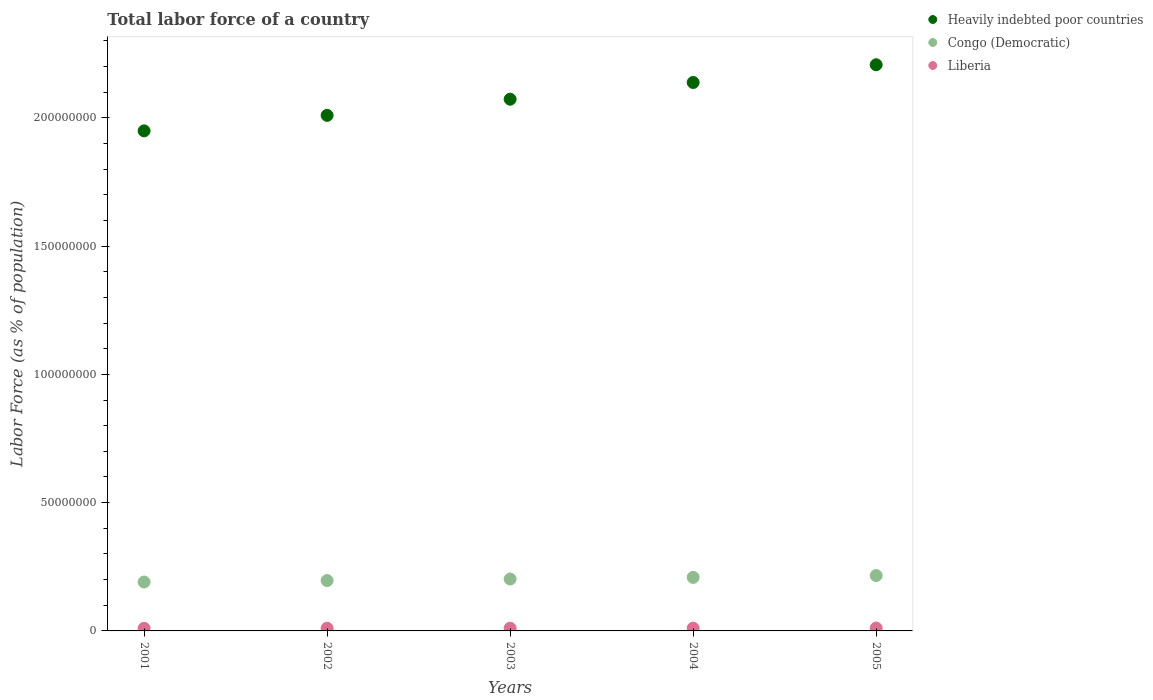How many different coloured dotlines are there?
Your answer should be very brief. 3. What is the percentage of labor force in Heavily indebted poor countries in 2002?
Provide a succinct answer. 2.01e+08. Across all years, what is the maximum percentage of labor force in Heavily indebted poor countries?
Offer a very short reply. 2.21e+08. Across all years, what is the minimum percentage of labor force in Liberia?
Offer a very short reply. 1.02e+06. In which year was the percentage of labor force in Liberia maximum?
Your answer should be very brief. 2005. In which year was the percentage of labor force in Congo (Democratic) minimum?
Your answer should be very brief. 2001. What is the total percentage of labor force in Liberia in the graph?
Make the answer very short. 5.37e+06. What is the difference between the percentage of labor force in Heavily indebted poor countries in 2001 and that in 2005?
Provide a succinct answer. -2.58e+07. What is the difference between the percentage of labor force in Liberia in 2004 and the percentage of labor force in Heavily indebted poor countries in 2003?
Your response must be concise. -2.06e+08. What is the average percentage of labor force in Liberia per year?
Your answer should be compact. 1.07e+06. In the year 2003, what is the difference between the percentage of labor force in Congo (Democratic) and percentage of labor force in Liberia?
Ensure brevity in your answer.  1.92e+07. In how many years, is the percentage of labor force in Congo (Democratic) greater than 210000000 %?
Provide a succinct answer. 0. What is the ratio of the percentage of labor force in Congo (Democratic) in 2001 to that in 2004?
Your answer should be compact. 0.91. Is the percentage of labor force in Heavily indebted poor countries in 2002 less than that in 2004?
Make the answer very short. Yes. What is the difference between the highest and the second highest percentage of labor force in Congo (Democratic)?
Make the answer very short. 7.05e+05. What is the difference between the highest and the lowest percentage of labor force in Congo (Democratic)?
Provide a short and direct response. 2.51e+06. In how many years, is the percentage of labor force in Congo (Democratic) greater than the average percentage of labor force in Congo (Democratic) taken over all years?
Provide a short and direct response. 2. Is the sum of the percentage of labor force in Heavily indebted poor countries in 2002 and 2003 greater than the maximum percentage of labor force in Congo (Democratic) across all years?
Give a very brief answer. Yes. Is it the case that in every year, the sum of the percentage of labor force in Congo (Democratic) and percentage of labor force in Heavily indebted poor countries  is greater than the percentage of labor force in Liberia?
Provide a succinct answer. Yes. Does the percentage of labor force in Liberia monotonically increase over the years?
Your answer should be very brief. Yes. Is the percentage of labor force in Liberia strictly greater than the percentage of labor force in Congo (Democratic) over the years?
Offer a very short reply. No. Is the percentage of labor force in Liberia strictly less than the percentage of labor force in Heavily indebted poor countries over the years?
Your answer should be compact. Yes. What is the difference between two consecutive major ticks on the Y-axis?
Make the answer very short. 5.00e+07. Are the values on the major ticks of Y-axis written in scientific E-notation?
Provide a short and direct response. No. Does the graph contain grids?
Provide a succinct answer. No. Where does the legend appear in the graph?
Your response must be concise. Top right. How are the legend labels stacked?
Your response must be concise. Vertical. What is the title of the graph?
Offer a terse response. Total labor force of a country. Does "Bolivia" appear as one of the legend labels in the graph?
Your answer should be very brief. No. What is the label or title of the Y-axis?
Give a very brief answer. Labor Force (as % of population). What is the Labor Force (as % of population) in Heavily indebted poor countries in 2001?
Make the answer very short. 1.95e+08. What is the Labor Force (as % of population) of Congo (Democratic) in 2001?
Your answer should be compact. 1.91e+07. What is the Labor Force (as % of population) in Liberia in 2001?
Your answer should be compact. 1.02e+06. What is the Labor Force (as % of population) in Heavily indebted poor countries in 2002?
Provide a succinct answer. 2.01e+08. What is the Labor Force (as % of population) of Congo (Democratic) in 2002?
Provide a succinct answer. 1.96e+07. What is the Labor Force (as % of population) in Liberia in 2002?
Your response must be concise. 1.05e+06. What is the Labor Force (as % of population) of Heavily indebted poor countries in 2003?
Offer a terse response. 2.07e+08. What is the Labor Force (as % of population) of Congo (Democratic) in 2003?
Your answer should be very brief. 2.02e+07. What is the Labor Force (as % of population) of Liberia in 2003?
Provide a succinct answer. 1.07e+06. What is the Labor Force (as % of population) in Heavily indebted poor countries in 2004?
Make the answer very short. 2.14e+08. What is the Labor Force (as % of population) of Congo (Democratic) in 2004?
Provide a short and direct response. 2.09e+07. What is the Labor Force (as % of population) in Liberia in 2004?
Keep it short and to the point. 1.09e+06. What is the Labor Force (as % of population) of Heavily indebted poor countries in 2005?
Provide a short and direct response. 2.21e+08. What is the Labor Force (as % of population) in Congo (Democratic) in 2005?
Your response must be concise. 2.16e+07. What is the Labor Force (as % of population) in Liberia in 2005?
Provide a short and direct response. 1.12e+06. Across all years, what is the maximum Labor Force (as % of population) of Heavily indebted poor countries?
Make the answer very short. 2.21e+08. Across all years, what is the maximum Labor Force (as % of population) of Congo (Democratic)?
Offer a very short reply. 2.16e+07. Across all years, what is the maximum Labor Force (as % of population) in Liberia?
Offer a terse response. 1.12e+06. Across all years, what is the minimum Labor Force (as % of population) in Heavily indebted poor countries?
Ensure brevity in your answer.  1.95e+08. Across all years, what is the minimum Labor Force (as % of population) of Congo (Democratic)?
Your response must be concise. 1.91e+07. Across all years, what is the minimum Labor Force (as % of population) in Liberia?
Keep it short and to the point. 1.02e+06. What is the total Labor Force (as % of population) in Heavily indebted poor countries in the graph?
Offer a very short reply. 1.04e+09. What is the total Labor Force (as % of population) in Congo (Democratic) in the graph?
Your answer should be compact. 1.01e+08. What is the total Labor Force (as % of population) in Liberia in the graph?
Provide a short and direct response. 5.37e+06. What is the difference between the Labor Force (as % of population) of Heavily indebted poor countries in 2001 and that in 2002?
Ensure brevity in your answer.  -6.04e+06. What is the difference between the Labor Force (as % of population) of Congo (Democratic) in 2001 and that in 2002?
Keep it short and to the point. -5.72e+05. What is the difference between the Labor Force (as % of population) in Liberia in 2001 and that in 2002?
Offer a terse response. -2.57e+04. What is the difference between the Labor Force (as % of population) of Heavily indebted poor countries in 2001 and that in 2003?
Offer a very short reply. -1.23e+07. What is the difference between the Labor Force (as % of population) of Congo (Democratic) in 2001 and that in 2003?
Keep it short and to the point. -1.17e+06. What is the difference between the Labor Force (as % of population) of Liberia in 2001 and that in 2003?
Ensure brevity in your answer.  -4.64e+04. What is the difference between the Labor Force (as % of population) of Heavily indebted poor countries in 2001 and that in 2004?
Give a very brief answer. -1.89e+07. What is the difference between the Labor Force (as % of population) in Congo (Democratic) in 2001 and that in 2004?
Your answer should be compact. -1.81e+06. What is the difference between the Labor Force (as % of population) in Liberia in 2001 and that in 2004?
Ensure brevity in your answer.  -6.97e+04. What is the difference between the Labor Force (as % of population) of Heavily indebted poor countries in 2001 and that in 2005?
Your answer should be compact. -2.58e+07. What is the difference between the Labor Force (as % of population) in Congo (Democratic) in 2001 and that in 2005?
Offer a terse response. -2.51e+06. What is the difference between the Labor Force (as % of population) of Liberia in 2001 and that in 2005?
Offer a terse response. -1.00e+05. What is the difference between the Labor Force (as % of population) in Heavily indebted poor countries in 2002 and that in 2003?
Your answer should be very brief. -6.30e+06. What is the difference between the Labor Force (as % of population) in Congo (Democratic) in 2002 and that in 2003?
Provide a succinct answer. -5.96e+05. What is the difference between the Labor Force (as % of population) of Liberia in 2002 and that in 2003?
Offer a very short reply. -2.07e+04. What is the difference between the Labor Force (as % of population) of Heavily indebted poor countries in 2002 and that in 2004?
Keep it short and to the point. -1.28e+07. What is the difference between the Labor Force (as % of population) in Congo (Democratic) in 2002 and that in 2004?
Your answer should be very brief. -1.23e+06. What is the difference between the Labor Force (as % of population) in Liberia in 2002 and that in 2004?
Your answer should be compact. -4.40e+04. What is the difference between the Labor Force (as % of population) in Heavily indebted poor countries in 2002 and that in 2005?
Keep it short and to the point. -1.97e+07. What is the difference between the Labor Force (as % of population) in Congo (Democratic) in 2002 and that in 2005?
Your answer should be compact. -1.94e+06. What is the difference between the Labor Force (as % of population) of Liberia in 2002 and that in 2005?
Your response must be concise. -7.46e+04. What is the difference between the Labor Force (as % of population) in Heavily indebted poor countries in 2003 and that in 2004?
Your answer should be compact. -6.52e+06. What is the difference between the Labor Force (as % of population) in Congo (Democratic) in 2003 and that in 2004?
Your answer should be compact. -6.39e+05. What is the difference between the Labor Force (as % of population) of Liberia in 2003 and that in 2004?
Make the answer very short. -2.33e+04. What is the difference between the Labor Force (as % of population) in Heavily indebted poor countries in 2003 and that in 2005?
Keep it short and to the point. -1.34e+07. What is the difference between the Labor Force (as % of population) of Congo (Democratic) in 2003 and that in 2005?
Ensure brevity in your answer.  -1.34e+06. What is the difference between the Labor Force (as % of population) of Liberia in 2003 and that in 2005?
Your response must be concise. -5.38e+04. What is the difference between the Labor Force (as % of population) of Heavily indebted poor countries in 2004 and that in 2005?
Your answer should be compact. -6.91e+06. What is the difference between the Labor Force (as % of population) of Congo (Democratic) in 2004 and that in 2005?
Give a very brief answer. -7.05e+05. What is the difference between the Labor Force (as % of population) of Liberia in 2004 and that in 2005?
Provide a succinct answer. -3.06e+04. What is the difference between the Labor Force (as % of population) in Heavily indebted poor countries in 2001 and the Labor Force (as % of population) in Congo (Democratic) in 2002?
Your answer should be compact. 1.75e+08. What is the difference between the Labor Force (as % of population) in Heavily indebted poor countries in 2001 and the Labor Force (as % of population) in Liberia in 2002?
Offer a terse response. 1.94e+08. What is the difference between the Labor Force (as % of population) of Congo (Democratic) in 2001 and the Labor Force (as % of population) of Liberia in 2002?
Provide a short and direct response. 1.80e+07. What is the difference between the Labor Force (as % of population) in Heavily indebted poor countries in 2001 and the Labor Force (as % of population) in Congo (Democratic) in 2003?
Your response must be concise. 1.75e+08. What is the difference between the Labor Force (as % of population) in Heavily indebted poor countries in 2001 and the Labor Force (as % of population) in Liberia in 2003?
Keep it short and to the point. 1.94e+08. What is the difference between the Labor Force (as % of population) of Congo (Democratic) in 2001 and the Labor Force (as % of population) of Liberia in 2003?
Offer a very short reply. 1.80e+07. What is the difference between the Labor Force (as % of population) of Heavily indebted poor countries in 2001 and the Labor Force (as % of population) of Congo (Democratic) in 2004?
Offer a terse response. 1.74e+08. What is the difference between the Labor Force (as % of population) in Heavily indebted poor countries in 2001 and the Labor Force (as % of population) in Liberia in 2004?
Offer a very short reply. 1.94e+08. What is the difference between the Labor Force (as % of population) in Congo (Democratic) in 2001 and the Labor Force (as % of population) in Liberia in 2004?
Your response must be concise. 1.80e+07. What is the difference between the Labor Force (as % of population) in Heavily indebted poor countries in 2001 and the Labor Force (as % of population) in Congo (Democratic) in 2005?
Give a very brief answer. 1.73e+08. What is the difference between the Labor Force (as % of population) of Heavily indebted poor countries in 2001 and the Labor Force (as % of population) of Liberia in 2005?
Provide a short and direct response. 1.94e+08. What is the difference between the Labor Force (as % of population) of Congo (Democratic) in 2001 and the Labor Force (as % of population) of Liberia in 2005?
Offer a very short reply. 1.79e+07. What is the difference between the Labor Force (as % of population) in Heavily indebted poor countries in 2002 and the Labor Force (as % of population) in Congo (Democratic) in 2003?
Make the answer very short. 1.81e+08. What is the difference between the Labor Force (as % of population) in Heavily indebted poor countries in 2002 and the Labor Force (as % of population) in Liberia in 2003?
Offer a terse response. 2.00e+08. What is the difference between the Labor Force (as % of population) of Congo (Democratic) in 2002 and the Labor Force (as % of population) of Liberia in 2003?
Offer a very short reply. 1.86e+07. What is the difference between the Labor Force (as % of population) in Heavily indebted poor countries in 2002 and the Labor Force (as % of population) in Congo (Democratic) in 2004?
Your response must be concise. 1.80e+08. What is the difference between the Labor Force (as % of population) of Heavily indebted poor countries in 2002 and the Labor Force (as % of population) of Liberia in 2004?
Give a very brief answer. 2.00e+08. What is the difference between the Labor Force (as % of population) in Congo (Democratic) in 2002 and the Labor Force (as % of population) in Liberia in 2004?
Your response must be concise. 1.85e+07. What is the difference between the Labor Force (as % of population) of Heavily indebted poor countries in 2002 and the Labor Force (as % of population) of Congo (Democratic) in 2005?
Offer a very short reply. 1.79e+08. What is the difference between the Labor Force (as % of population) in Heavily indebted poor countries in 2002 and the Labor Force (as % of population) in Liberia in 2005?
Ensure brevity in your answer.  2.00e+08. What is the difference between the Labor Force (as % of population) in Congo (Democratic) in 2002 and the Labor Force (as % of population) in Liberia in 2005?
Ensure brevity in your answer.  1.85e+07. What is the difference between the Labor Force (as % of population) of Heavily indebted poor countries in 2003 and the Labor Force (as % of population) of Congo (Democratic) in 2004?
Offer a terse response. 1.86e+08. What is the difference between the Labor Force (as % of population) in Heavily indebted poor countries in 2003 and the Labor Force (as % of population) in Liberia in 2004?
Provide a short and direct response. 2.06e+08. What is the difference between the Labor Force (as % of population) of Congo (Democratic) in 2003 and the Labor Force (as % of population) of Liberia in 2004?
Make the answer very short. 1.91e+07. What is the difference between the Labor Force (as % of population) of Heavily indebted poor countries in 2003 and the Labor Force (as % of population) of Congo (Democratic) in 2005?
Ensure brevity in your answer.  1.86e+08. What is the difference between the Labor Force (as % of population) in Heavily indebted poor countries in 2003 and the Labor Force (as % of population) in Liberia in 2005?
Keep it short and to the point. 2.06e+08. What is the difference between the Labor Force (as % of population) of Congo (Democratic) in 2003 and the Labor Force (as % of population) of Liberia in 2005?
Make the answer very short. 1.91e+07. What is the difference between the Labor Force (as % of population) in Heavily indebted poor countries in 2004 and the Labor Force (as % of population) in Congo (Democratic) in 2005?
Your answer should be compact. 1.92e+08. What is the difference between the Labor Force (as % of population) in Heavily indebted poor countries in 2004 and the Labor Force (as % of population) in Liberia in 2005?
Make the answer very short. 2.13e+08. What is the difference between the Labor Force (as % of population) of Congo (Democratic) in 2004 and the Labor Force (as % of population) of Liberia in 2005?
Your answer should be compact. 1.97e+07. What is the average Labor Force (as % of population) of Heavily indebted poor countries per year?
Provide a succinct answer. 2.08e+08. What is the average Labor Force (as % of population) in Congo (Democratic) per year?
Keep it short and to the point. 2.03e+07. What is the average Labor Force (as % of population) in Liberia per year?
Your response must be concise. 1.07e+06. In the year 2001, what is the difference between the Labor Force (as % of population) in Heavily indebted poor countries and Labor Force (as % of population) in Congo (Democratic)?
Offer a terse response. 1.76e+08. In the year 2001, what is the difference between the Labor Force (as % of population) in Heavily indebted poor countries and Labor Force (as % of population) in Liberia?
Make the answer very short. 1.94e+08. In the year 2001, what is the difference between the Labor Force (as % of population) of Congo (Democratic) and Labor Force (as % of population) of Liberia?
Offer a very short reply. 1.80e+07. In the year 2002, what is the difference between the Labor Force (as % of population) in Heavily indebted poor countries and Labor Force (as % of population) in Congo (Democratic)?
Your answer should be very brief. 1.81e+08. In the year 2002, what is the difference between the Labor Force (as % of population) of Heavily indebted poor countries and Labor Force (as % of population) of Liberia?
Provide a short and direct response. 2.00e+08. In the year 2002, what is the difference between the Labor Force (as % of population) of Congo (Democratic) and Labor Force (as % of population) of Liberia?
Your response must be concise. 1.86e+07. In the year 2003, what is the difference between the Labor Force (as % of population) in Heavily indebted poor countries and Labor Force (as % of population) in Congo (Democratic)?
Your answer should be very brief. 1.87e+08. In the year 2003, what is the difference between the Labor Force (as % of population) of Heavily indebted poor countries and Labor Force (as % of population) of Liberia?
Ensure brevity in your answer.  2.06e+08. In the year 2003, what is the difference between the Labor Force (as % of population) of Congo (Democratic) and Labor Force (as % of population) of Liberia?
Your response must be concise. 1.92e+07. In the year 2004, what is the difference between the Labor Force (as % of population) in Heavily indebted poor countries and Labor Force (as % of population) in Congo (Democratic)?
Your answer should be compact. 1.93e+08. In the year 2004, what is the difference between the Labor Force (as % of population) of Heavily indebted poor countries and Labor Force (as % of population) of Liberia?
Give a very brief answer. 2.13e+08. In the year 2004, what is the difference between the Labor Force (as % of population) in Congo (Democratic) and Labor Force (as % of population) in Liberia?
Your answer should be very brief. 1.98e+07. In the year 2005, what is the difference between the Labor Force (as % of population) in Heavily indebted poor countries and Labor Force (as % of population) in Congo (Democratic)?
Provide a succinct answer. 1.99e+08. In the year 2005, what is the difference between the Labor Force (as % of population) in Heavily indebted poor countries and Labor Force (as % of population) in Liberia?
Provide a succinct answer. 2.20e+08. In the year 2005, what is the difference between the Labor Force (as % of population) in Congo (Democratic) and Labor Force (as % of population) in Liberia?
Your response must be concise. 2.05e+07. What is the ratio of the Labor Force (as % of population) of Heavily indebted poor countries in 2001 to that in 2002?
Give a very brief answer. 0.97. What is the ratio of the Labor Force (as % of population) of Congo (Democratic) in 2001 to that in 2002?
Your response must be concise. 0.97. What is the ratio of the Labor Force (as % of population) of Liberia in 2001 to that in 2002?
Provide a succinct answer. 0.98. What is the ratio of the Labor Force (as % of population) in Heavily indebted poor countries in 2001 to that in 2003?
Offer a terse response. 0.94. What is the ratio of the Labor Force (as % of population) in Congo (Democratic) in 2001 to that in 2003?
Offer a terse response. 0.94. What is the ratio of the Labor Force (as % of population) in Liberia in 2001 to that in 2003?
Ensure brevity in your answer.  0.96. What is the ratio of the Labor Force (as % of population) of Heavily indebted poor countries in 2001 to that in 2004?
Provide a succinct answer. 0.91. What is the ratio of the Labor Force (as % of population) in Congo (Democratic) in 2001 to that in 2004?
Offer a terse response. 0.91. What is the ratio of the Labor Force (as % of population) in Liberia in 2001 to that in 2004?
Your response must be concise. 0.94. What is the ratio of the Labor Force (as % of population) of Heavily indebted poor countries in 2001 to that in 2005?
Provide a short and direct response. 0.88. What is the ratio of the Labor Force (as % of population) in Congo (Democratic) in 2001 to that in 2005?
Provide a short and direct response. 0.88. What is the ratio of the Labor Force (as % of population) of Liberia in 2001 to that in 2005?
Make the answer very short. 0.91. What is the ratio of the Labor Force (as % of population) in Heavily indebted poor countries in 2002 to that in 2003?
Make the answer very short. 0.97. What is the ratio of the Labor Force (as % of population) in Congo (Democratic) in 2002 to that in 2003?
Provide a short and direct response. 0.97. What is the ratio of the Labor Force (as % of population) in Liberia in 2002 to that in 2003?
Keep it short and to the point. 0.98. What is the ratio of the Labor Force (as % of population) in Heavily indebted poor countries in 2002 to that in 2004?
Offer a terse response. 0.94. What is the ratio of the Labor Force (as % of population) in Congo (Democratic) in 2002 to that in 2004?
Provide a succinct answer. 0.94. What is the ratio of the Labor Force (as % of population) of Liberia in 2002 to that in 2004?
Your answer should be compact. 0.96. What is the ratio of the Labor Force (as % of population) in Heavily indebted poor countries in 2002 to that in 2005?
Keep it short and to the point. 0.91. What is the ratio of the Labor Force (as % of population) of Congo (Democratic) in 2002 to that in 2005?
Keep it short and to the point. 0.91. What is the ratio of the Labor Force (as % of population) in Liberia in 2002 to that in 2005?
Provide a succinct answer. 0.93. What is the ratio of the Labor Force (as % of population) in Heavily indebted poor countries in 2003 to that in 2004?
Provide a short and direct response. 0.97. What is the ratio of the Labor Force (as % of population) in Congo (Democratic) in 2003 to that in 2004?
Provide a short and direct response. 0.97. What is the ratio of the Labor Force (as % of population) of Liberia in 2003 to that in 2004?
Your answer should be very brief. 0.98. What is the ratio of the Labor Force (as % of population) in Heavily indebted poor countries in 2003 to that in 2005?
Keep it short and to the point. 0.94. What is the ratio of the Labor Force (as % of population) of Congo (Democratic) in 2003 to that in 2005?
Provide a short and direct response. 0.94. What is the ratio of the Labor Force (as % of population) of Liberia in 2003 to that in 2005?
Keep it short and to the point. 0.95. What is the ratio of the Labor Force (as % of population) of Heavily indebted poor countries in 2004 to that in 2005?
Provide a short and direct response. 0.97. What is the ratio of the Labor Force (as % of population) of Congo (Democratic) in 2004 to that in 2005?
Your answer should be very brief. 0.97. What is the ratio of the Labor Force (as % of population) in Liberia in 2004 to that in 2005?
Make the answer very short. 0.97. What is the difference between the highest and the second highest Labor Force (as % of population) of Heavily indebted poor countries?
Your response must be concise. 6.91e+06. What is the difference between the highest and the second highest Labor Force (as % of population) in Congo (Democratic)?
Offer a terse response. 7.05e+05. What is the difference between the highest and the second highest Labor Force (as % of population) in Liberia?
Your answer should be very brief. 3.06e+04. What is the difference between the highest and the lowest Labor Force (as % of population) in Heavily indebted poor countries?
Make the answer very short. 2.58e+07. What is the difference between the highest and the lowest Labor Force (as % of population) of Congo (Democratic)?
Provide a short and direct response. 2.51e+06. What is the difference between the highest and the lowest Labor Force (as % of population) in Liberia?
Give a very brief answer. 1.00e+05. 